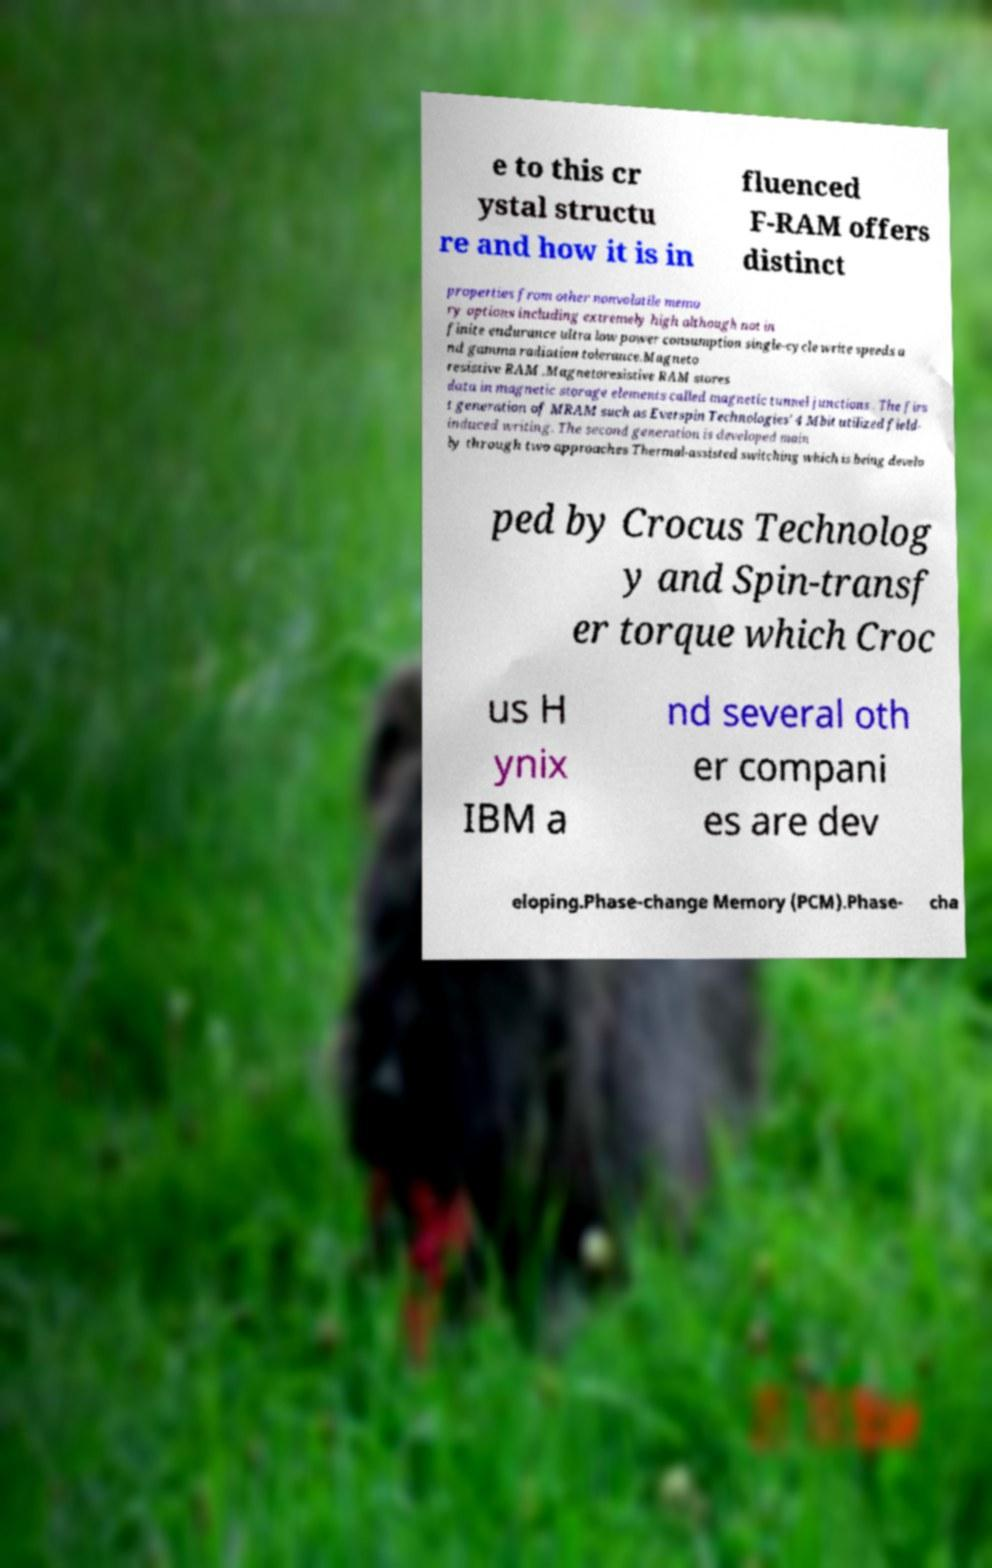There's text embedded in this image that I need extracted. Can you transcribe it verbatim? e to this cr ystal structu re and how it is in fluenced F-RAM offers distinct properties from other nonvolatile memo ry options including extremely high although not in finite endurance ultra low power consumption single-cycle write speeds a nd gamma radiation tolerance.Magneto resistive RAM .Magnetoresistive RAM stores data in magnetic storage elements called magnetic tunnel junctions . The firs t generation of MRAM such as Everspin Technologies' 4 Mbit utilized field- induced writing. The second generation is developed main ly through two approaches Thermal-assisted switching which is being develo ped by Crocus Technolog y and Spin-transf er torque which Croc us H ynix IBM a nd several oth er compani es are dev eloping.Phase-change Memory (PCM).Phase- cha 